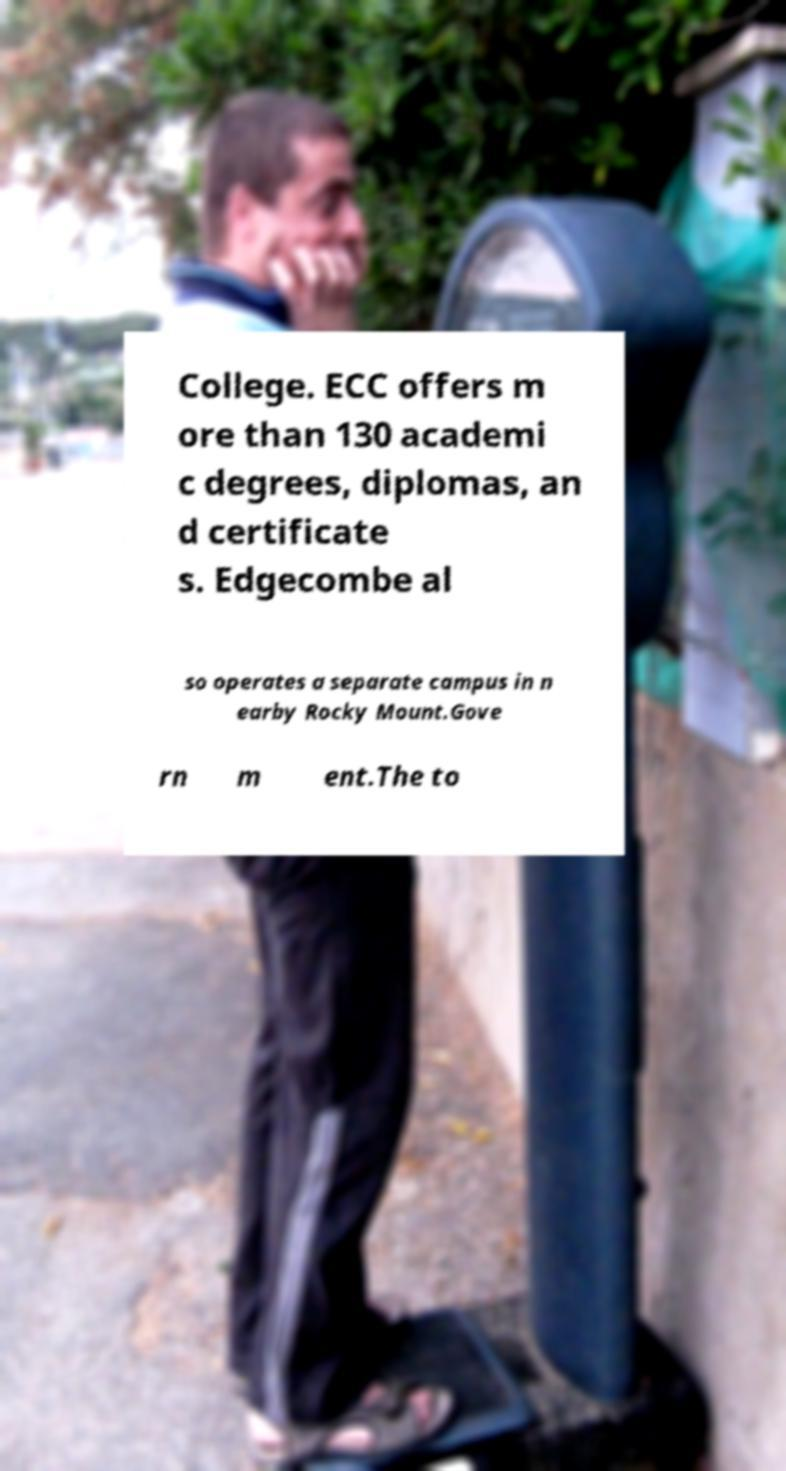There's text embedded in this image that I need extracted. Can you transcribe it verbatim? College. ECC offers m ore than 130 academi c degrees, diplomas, an d certificate s. Edgecombe al so operates a separate campus in n earby Rocky Mount.Gove rn m ent.The to 